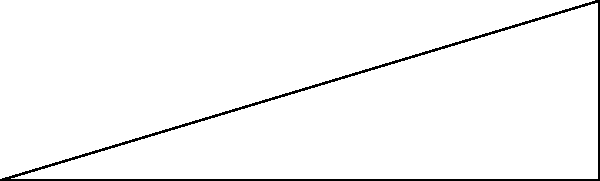As a truck driver, you're approaching a steep incline on the highway. The road maintenance crew has placed markers indicating that over a horizontal distance of 30 meters, the road rises 9 meters in height. What is the angle of inclination ($\theta$) of this slope? Round your answer to the nearest degree. To solve this problem, we can use trigonometry, specifically the tangent function. Let's break it down step-by-step:

1) In a right triangle, tangent of an angle is the ratio of the opposite side to the adjacent side.

2) In this case:
   - The rise (opposite side) is 9 meters
   - The horizontal distance (adjacent side) is 30 meters

3) We can set up the equation:
   
   $\tan(\theta) = \frac{\text{opposite}}{\text{adjacent}} = \frac{9}{30}$

4) To find $\theta$, we need to use the inverse tangent (arctan) function:

   $\theta = \arctan(\frac{9}{30})$

5) Using a calculator:

   $\theta = \arctan(0.3) \approx 16.70^\circ$

6) Rounding to the nearest degree:

   $\theta \approx 17^\circ$

This angle of inclination is quite significant for a highway, which is why it's important for truck drivers to be aware of such slopes for safe driving and appropriate gear selection.
Answer: $17^\circ$ 